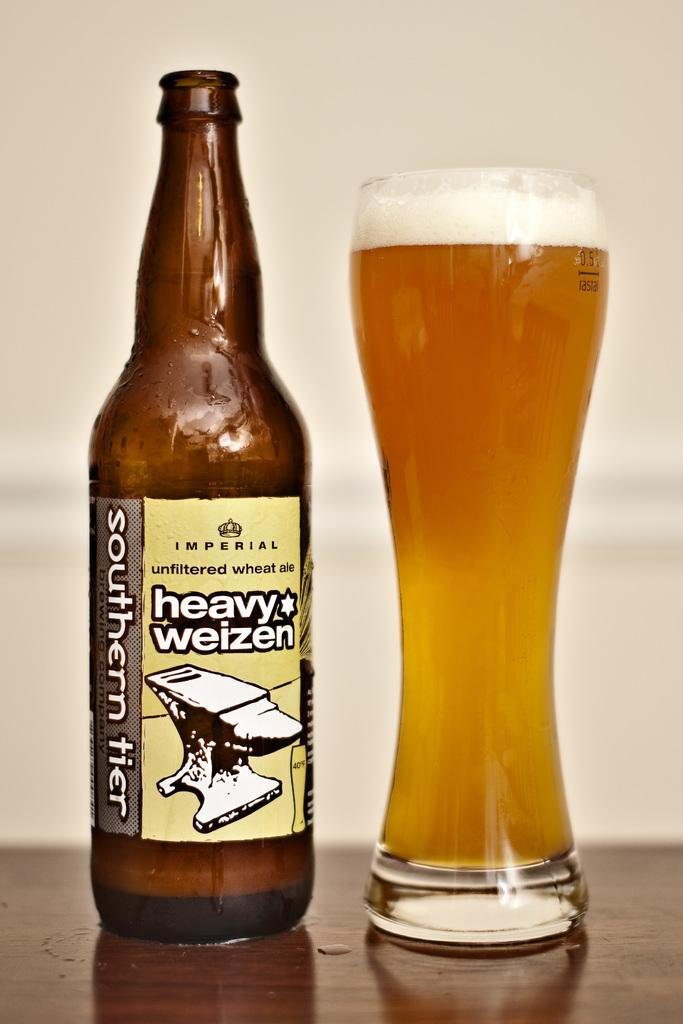<image>
Write a terse but informative summary of the picture. a bottle of heavy weisen beer next to a glass 